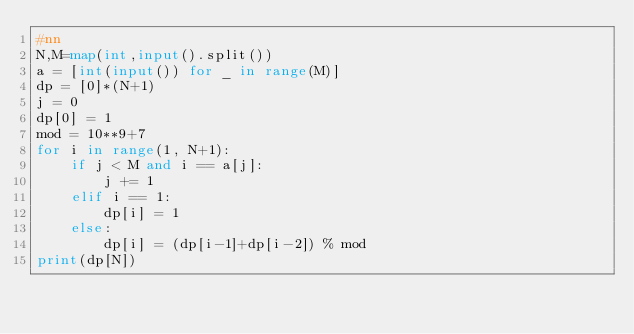<code> <loc_0><loc_0><loc_500><loc_500><_Python_>#nn
N,M=map(int,input().split())
a = [int(input()) for _ in range(M)]
dp = [0]*(N+1)
j = 0
dp[0] = 1
mod = 10**9+7
for i in range(1, N+1):
    if j < M and i == a[j]:
        j += 1
    elif i == 1:
        dp[i] = 1
    else:
        dp[i] = (dp[i-1]+dp[i-2]) % mod
print(dp[N])</code> 